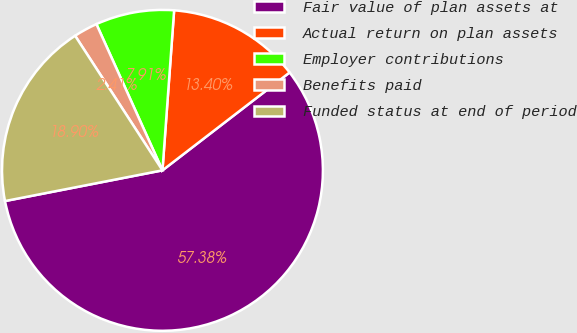Convert chart to OTSL. <chart><loc_0><loc_0><loc_500><loc_500><pie_chart><fcel>Fair value of plan assets at<fcel>Actual return on plan assets<fcel>Employer contributions<fcel>Benefits paid<fcel>Funded status at end of period<nl><fcel>57.37%<fcel>13.4%<fcel>7.91%<fcel>2.41%<fcel>18.9%<nl></chart> 